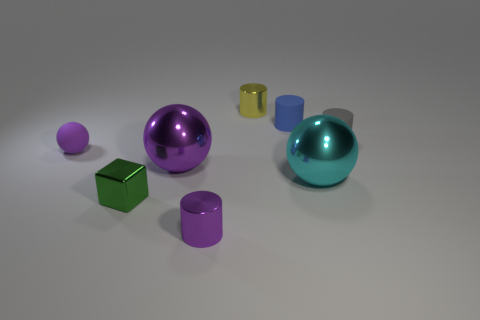Can you describe the colors and shapes of the objects present in the image? Certainly! The image showcases a collection of geometric shapes including two spheres, one large cyan and one smaller magenta; a green cube; two cylinders, one shiny purple and one smaller yellow; each distinct in color and size, posed against a neutral background. 